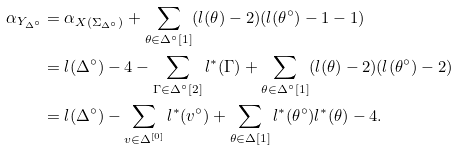Convert formula to latex. <formula><loc_0><loc_0><loc_500><loc_500>\alpha _ { Y _ { \Delta ^ { \circ } } } & = \alpha _ { X ( { \Sigma _ { \Delta ^ { \circ } } } ) } + \sum _ { \theta \in { \Delta ^ { \circ } } [ 1 ] } ( l ( \theta ) - 2 ) ( l ( \theta ^ { \circ } ) - 1 - 1 ) \\ & = l ( \Delta ^ { \circ } ) - 4 - \sum _ { \Gamma \in { \Delta ^ { \circ } } [ 2 ] } l ^ { * } ( \Gamma ) + \sum _ { \theta \in { \Delta ^ { \circ } } [ 1 ] } ( l ( \theta ) - 2 ) ( l ( \theta ^ { \circ } ) - 2 ) \\ & = l ( \Delta ^ { \circ } ) - \sum _ { v \in { \Delta } ^ { [ 0 ] } } l ^ { * } ( v ^ { \circ } ) + \sum _ { \theta \in { \Delta } [ 1 ] } l ^ { * } ( \theta ^ { \circ } ) l ^ { * } ( \theta ) - 4 .</formula> 